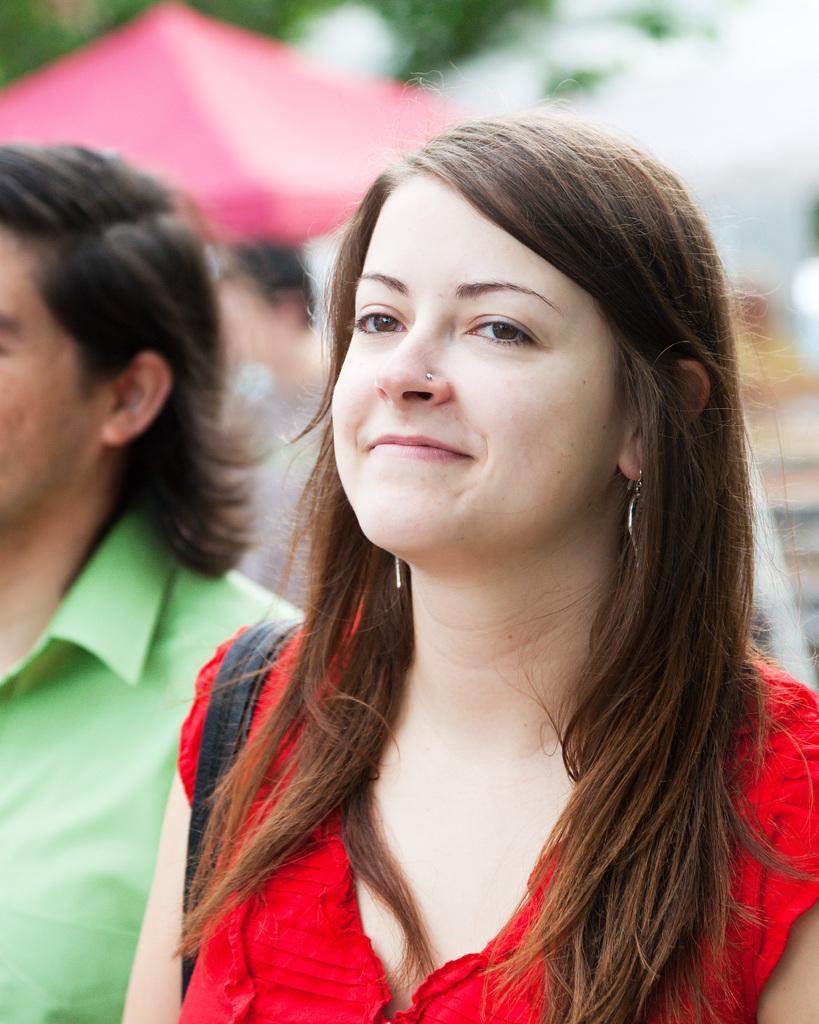Please provide a concise description of this image. In the foreground of this image, there is a woman in red dress wearing a bag. Beside her, there is a man in green shirt. In the background, image is blurred. 